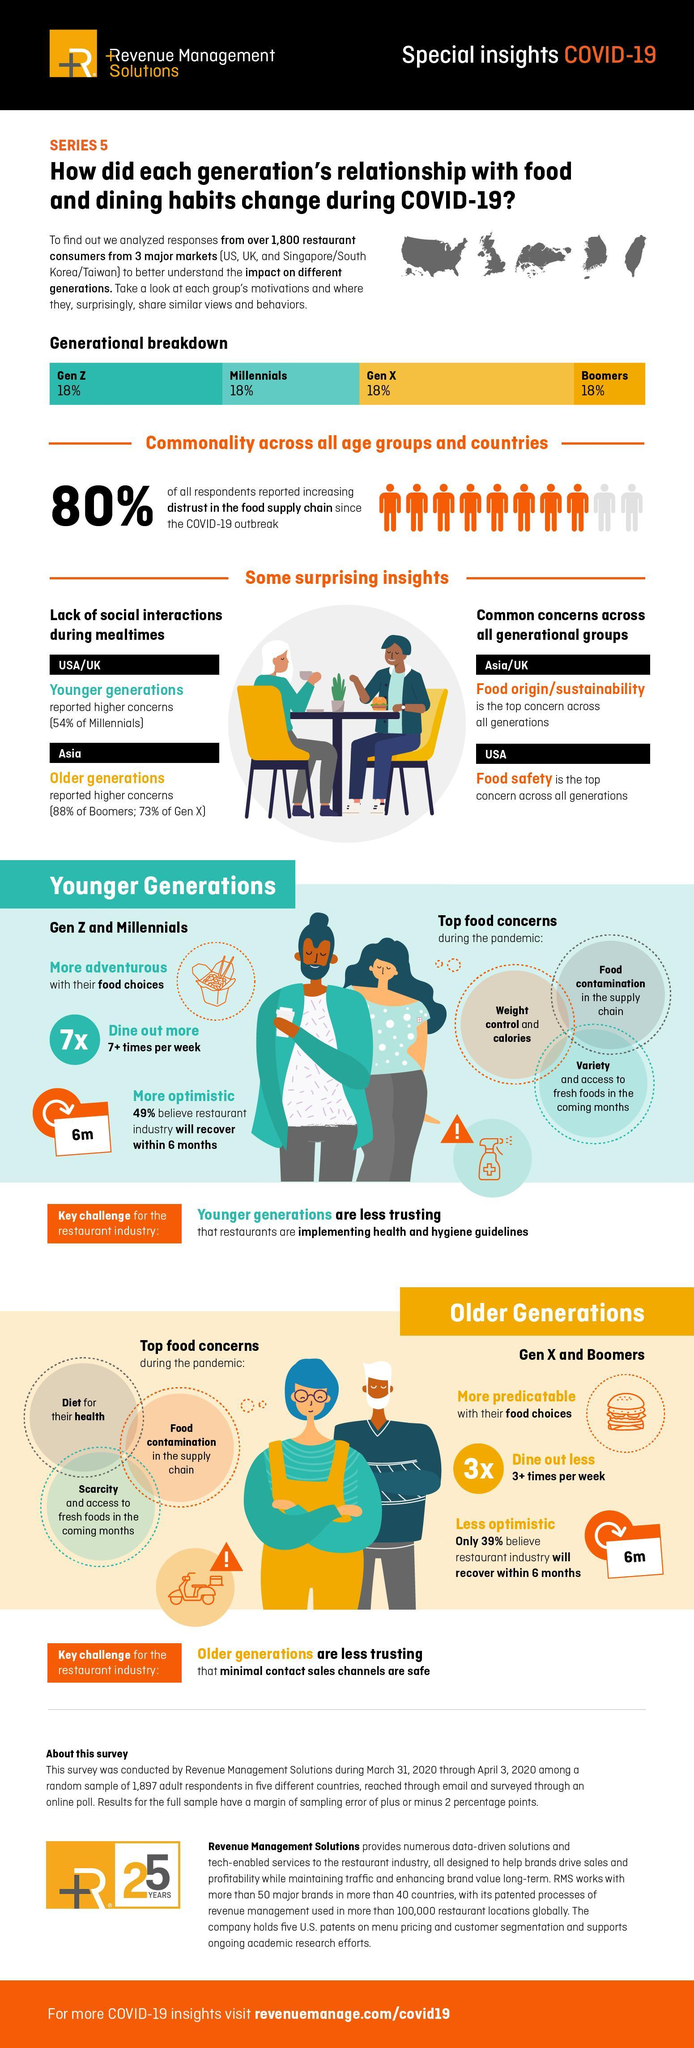Which generations are more adventurous with their food choices?
Answer the question with a short phrase. Gen Z and Millennials What do older generations distrust about restaurants? that minimal contact sales channels are safe What is the main concern across all generations in USA? Food safety Who are skeptical about restaurants implementing health and hygiene guidelines? Younger generations What is a common concern across all generations in Asia/UK ? Food origin/sustainability In USA and UK who expressed concerns about lack of social interactions during mealtimes? Younger generations Which generations are more predictable with their food choices? Gen X and Boomers 